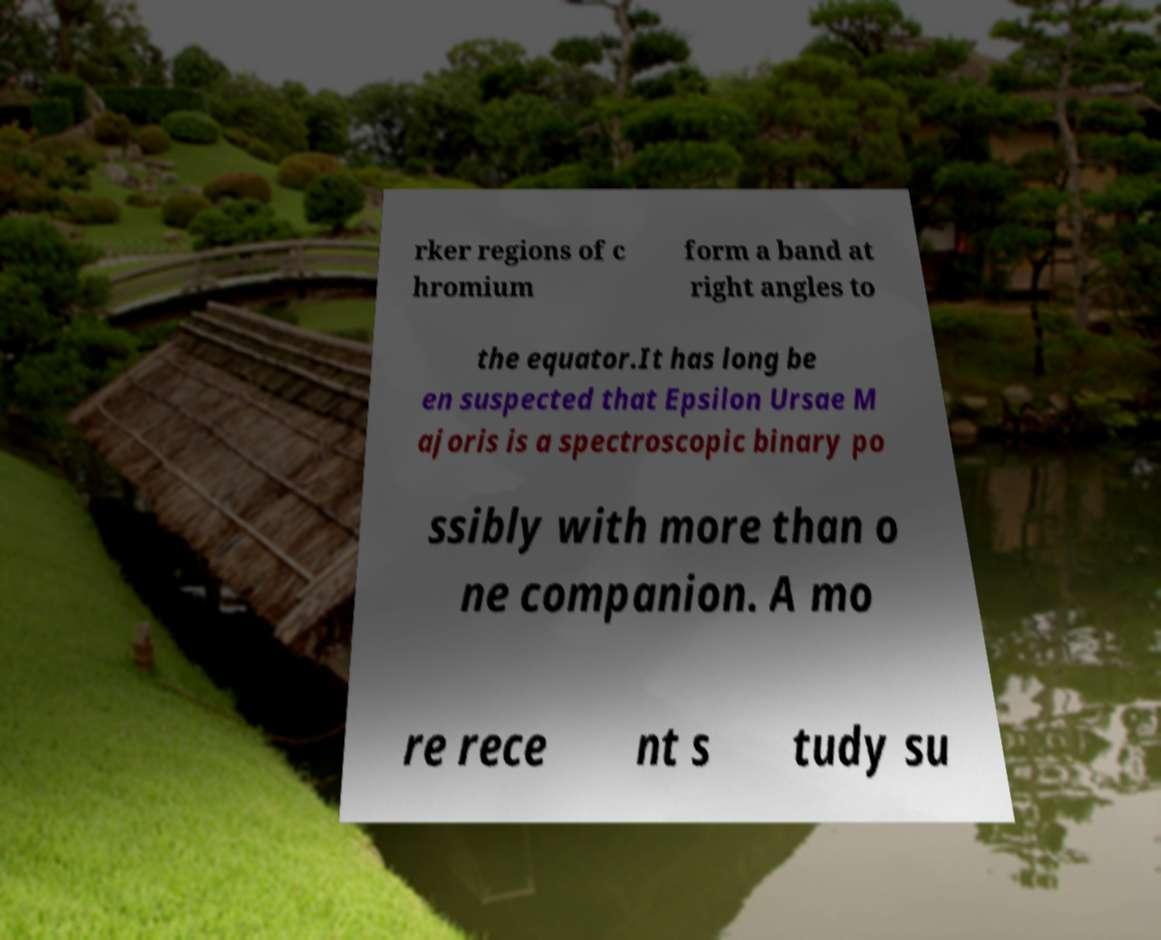Please identify and transcribe the text found in this image. rker regions of c hromium form a band at right angles to the equator.It has long be en suspected that Epsilon Ursae M ajoris is a spectroscopic binary po ssibly with more than o ne companion. A mo re rece nt s tudy su 